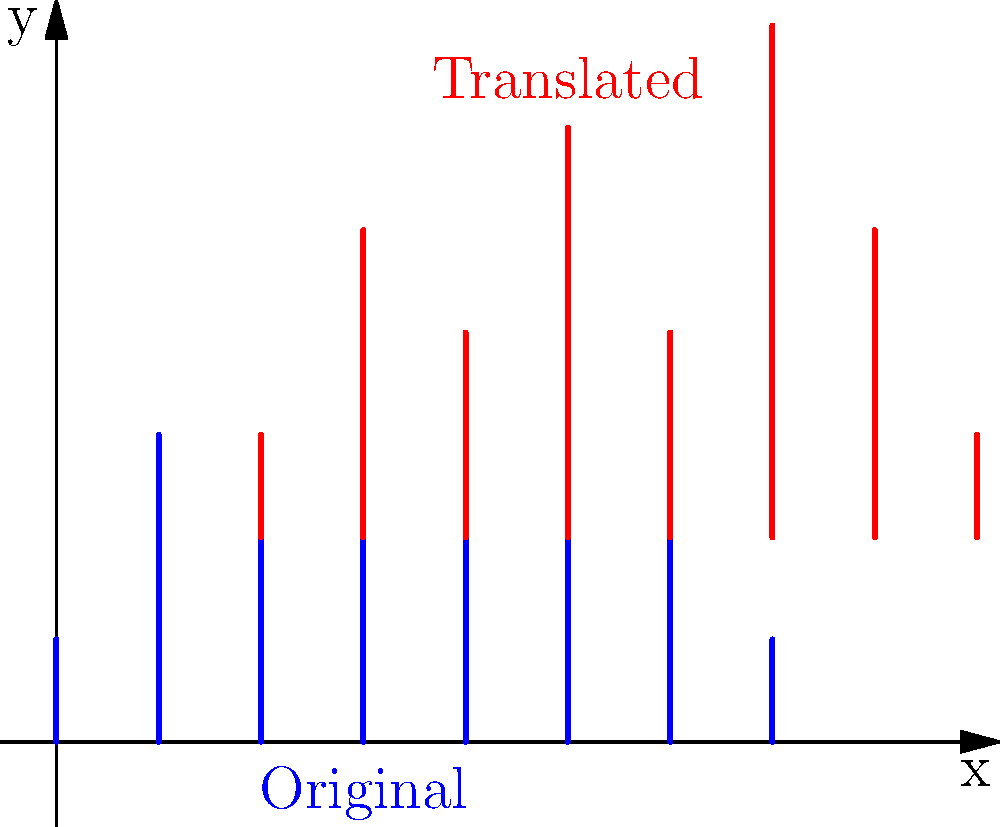In the diagram, a set of equalizer bars (shown in blue) has been translated to create a new audio pattern (shown in red). If the translation is represented by the vector $\mathbf{v} = (a, b)$, determine the values of $a$ and $b$. Then, calculate the area of the parallelogram formed by $\mathbf{v}$ and the vector $\mathbf{u} = (3, 1)$. Let's approach this step-by-step:

1) To find the translation vector $\mathbf{v} = (a, b)$:
   - Observe that each bar has moved 2 units to the right, so $a = 2$
   - Each bar has also moved 2 units up, so $b = 2$
   - Therefore, $\mathbf{v} = (2, 2)$

2) Now we need to calculate the area of the parallelogram formed by $\mathbf{v} = (2, 2)$ and $\mathbf{u} = (3, 1)$

3) The area of a parallelogram formed by two vectors can be calculated using the magnitude of the cross product of these vectors:
   
   Area = $|\mathbf{v} \times \mathbf{u}|$

4) For 2D vectors $(x_1, y_1)$ and $(x_2, y_2)$, the magnitude of the cross product is given by:
   
   $|x_1y_2 - y_1x_2|$

5) Substituting our vectors:
   
   Area = $|(2 \cdot 1) - (2 \cdot 3)|$
        = $|2 - 6|$
        = $|-4|$
        = $4$

Therefore, the area of the parallelogram is 4 square units.
Answer: $\mathbf{v} = (2, 2)$; Area = 4 